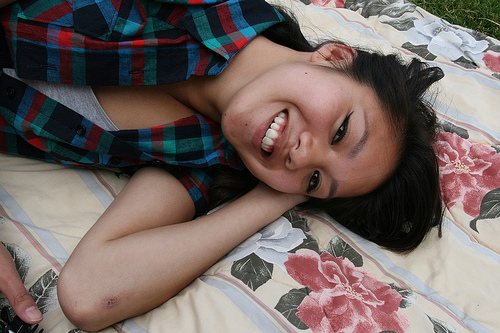<image>
Is the girl in front of the bed? No. The girl is not in front of the bed. The spatial positioning shows a different relationship between these objects. 